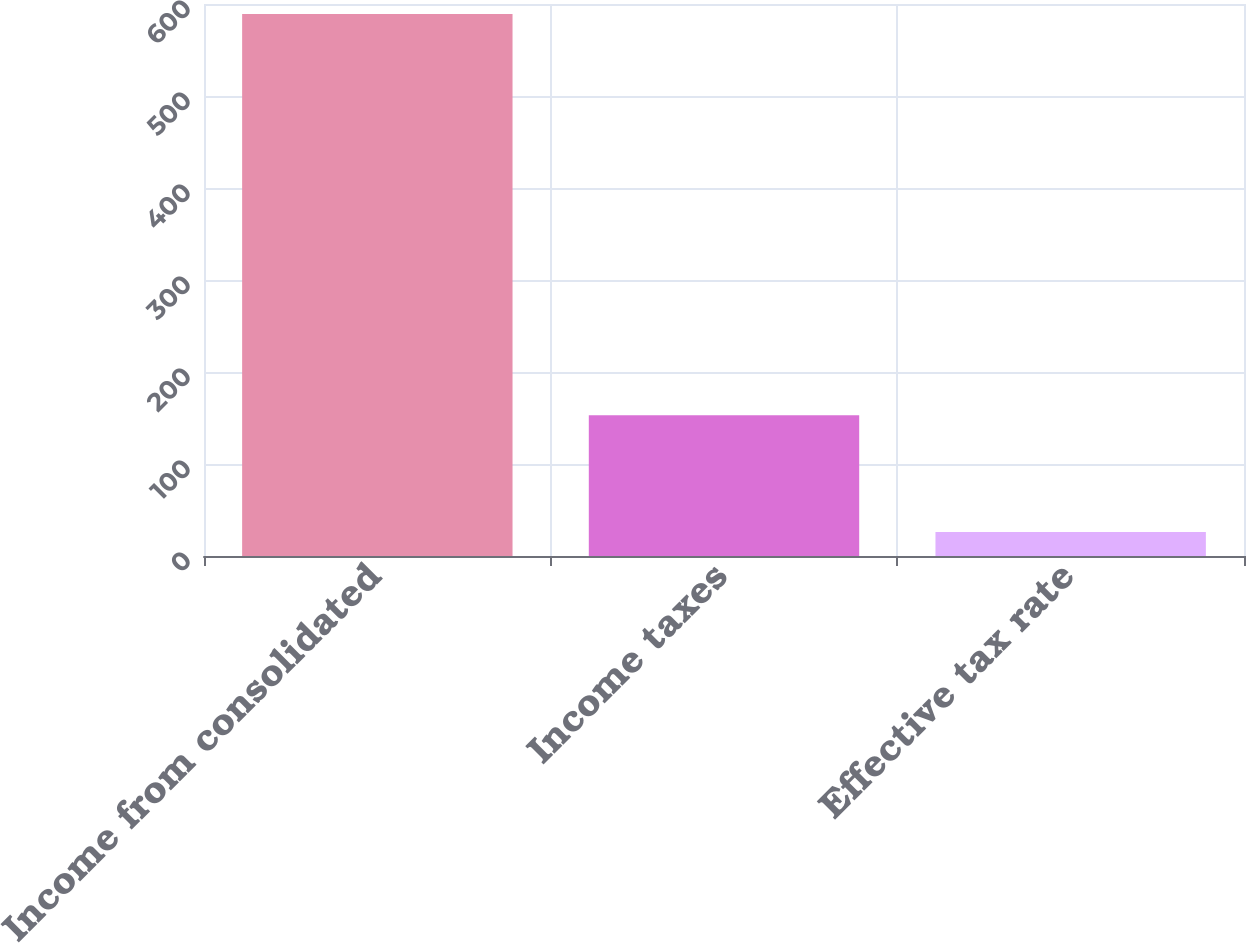Convert chart to OTSL. <chart><loc_0><loc_0><loc_500><loc_500><bar_chart><fcel>Income from consolidated<fcel>Income taxes<fcel>Effective tax rate<nl><fcel>589.2<fcel>153<fcel>26<nl></chart> 